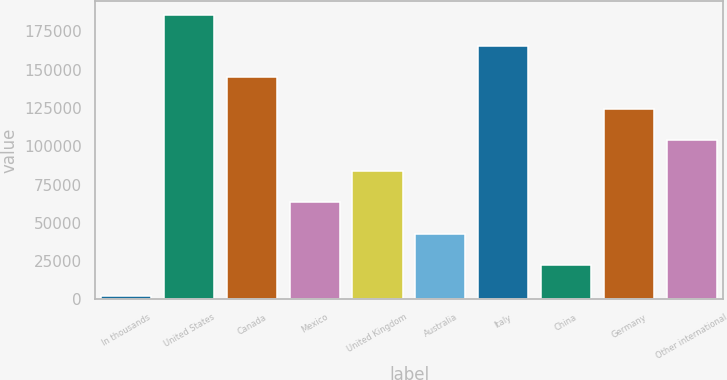<chart> <loc_0><loc_0><loc_500><loc_500><bar_chart><fcel>In thousands<fcel>United States<fcel>Canada<fcel>Mexico<fcel>United Kingdom<fcel>Australia<fcel>Italy<fcel>China<fcel>Germany<fcel>Other international<nl><fcel>2010<fcel>185804<fcel>144960<fcel>63274.5<fcel>83696<fcel>42853<fcel>165382<fcel>22431.5<fcel>124539<fcel>104118<nl></chart> 